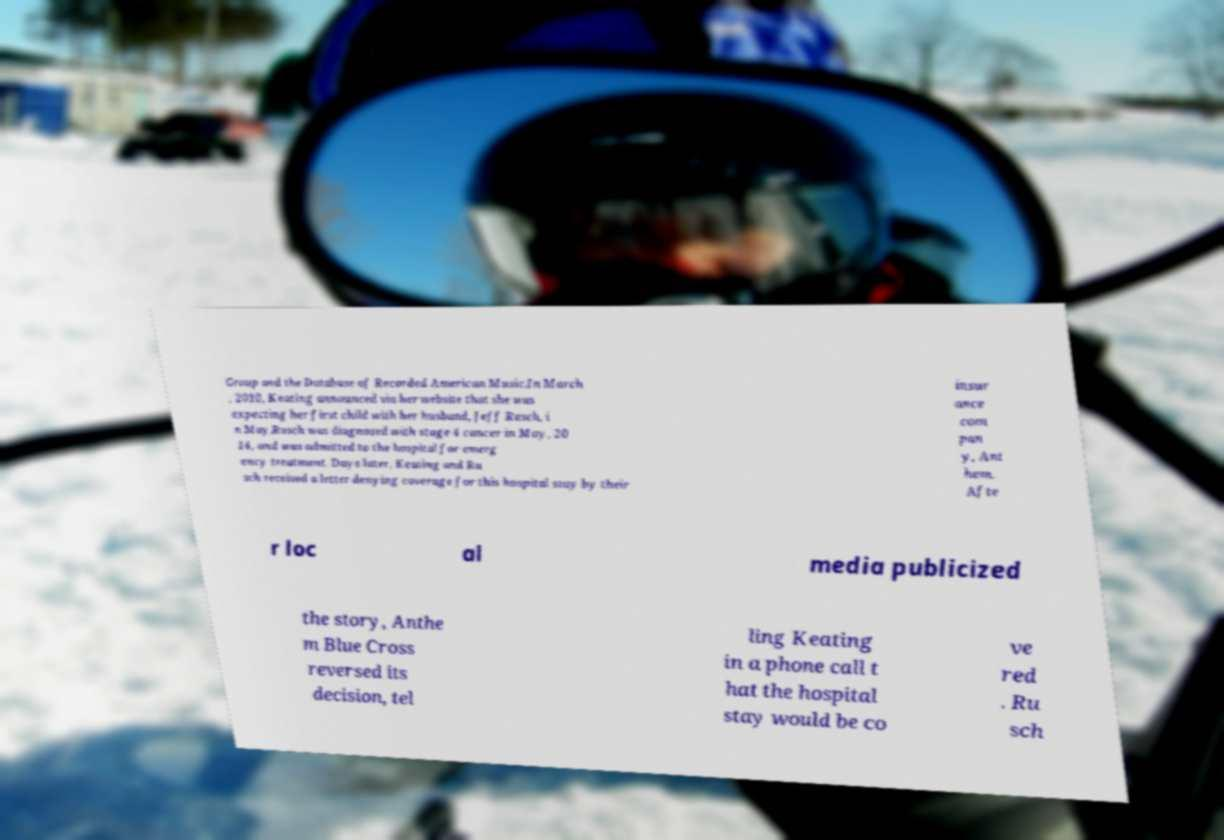Please identify and transcribe the text found in this image. Group and the Database of Recorded American Music.In March , 2010, Keating announced via her website that she was expecting her first child with her husband, Jeff Rusch, i n May.Rusch was diagnosed with stage 4 cancer in May, 20 14, and was admitted to the hospital for emerg ency treatment. Days later, Keating and Ru sch received a letter denying coverage for this hospital stay by their insur ance com pan y, Ant hem. Afte r loc al media publicized the story, Anthe m Blue Cross reversed its decision, tel ling Keating in a phone call t hat the hospital stay would be co ve red . Ru sch 